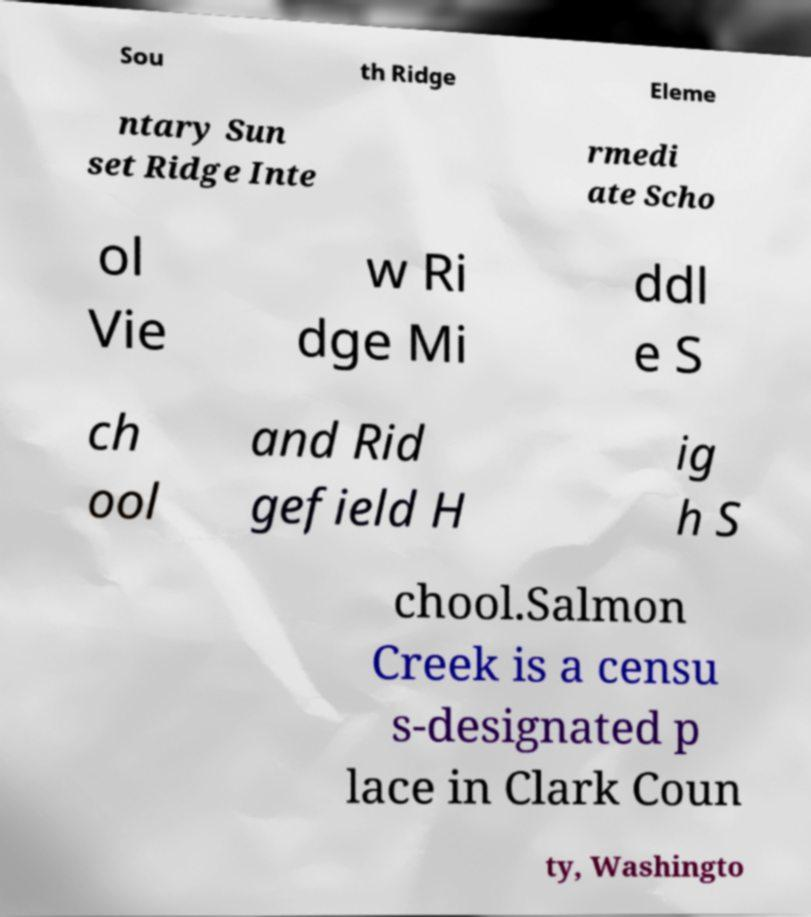What messages or text are displayed in this image? I need them in a readable, typed format. Sou th Ridge Eleme ntary Sun set Ridge Inte rmedi ate Scho ol Vie w Ri dge Mi ddl e S ch ool and Rid gefield H ig h S chool.Salmon Creek is a censu s-designated p lace in Clark Coun ty, Washingto 